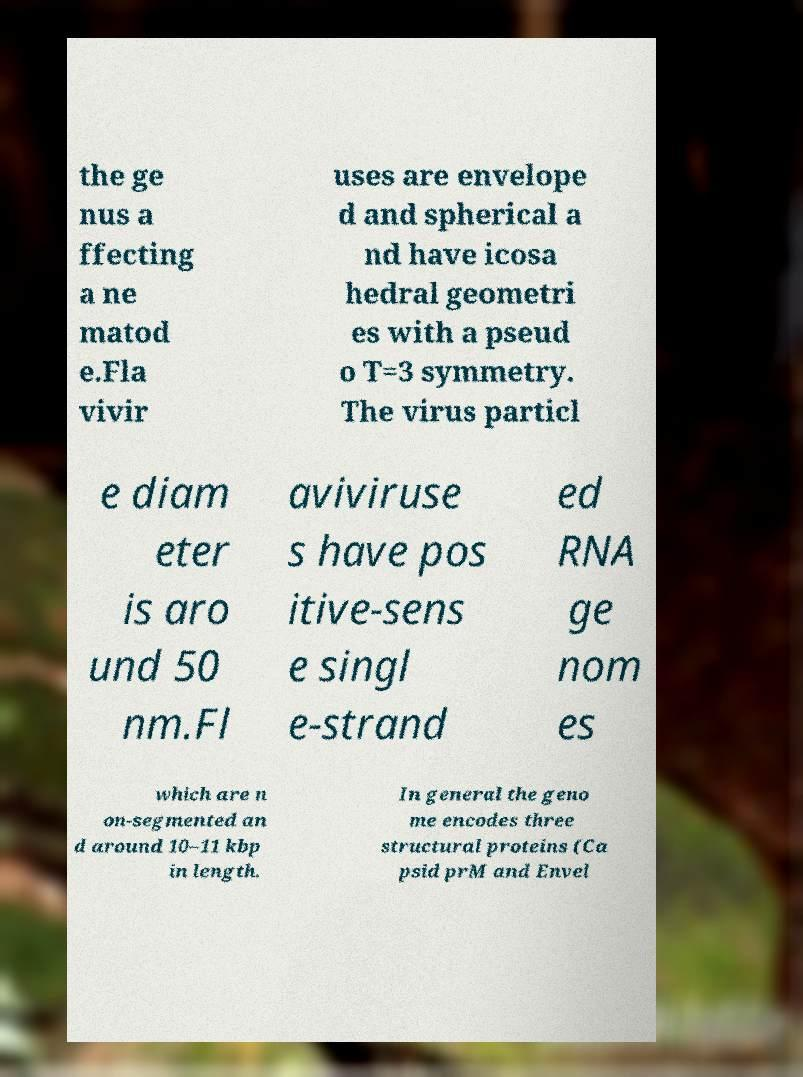For documentation purposes, I need the text within this image transcribed. Could you provide that? the ge nus a ffecting a ne matod e.Fla vivir uses are envelope d and spherical a nd have icosa hedral geometri es with a pseud o T=3 symmetry. The virus particl e diam eter is aro und 50 nm.Fl aviviruse s have pos itive-sens e singl e-strand ed RNA ge nom es which are n on-segmented an d around 10–11 kbp in length. In general the geno me encodes three structural proteins (Ca psid prM and Envel 